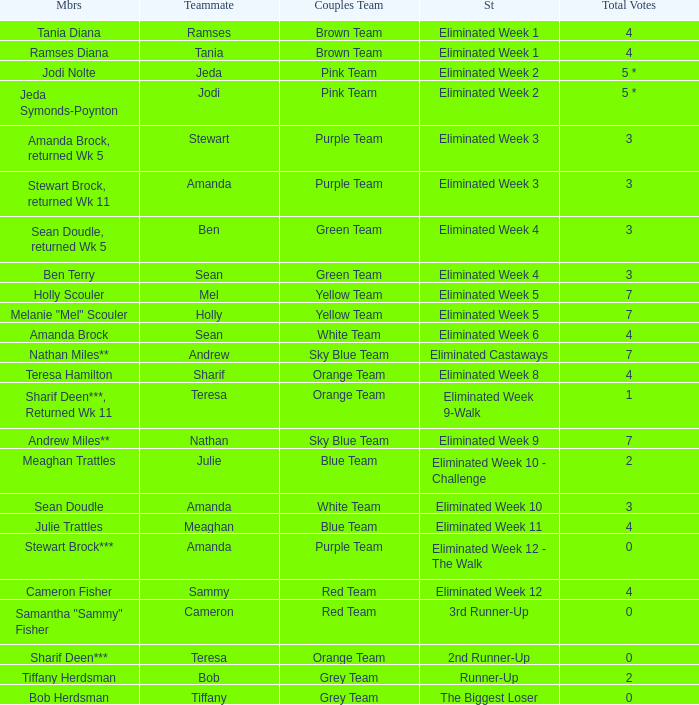What was Holly Scouler's total votes 7.0. 